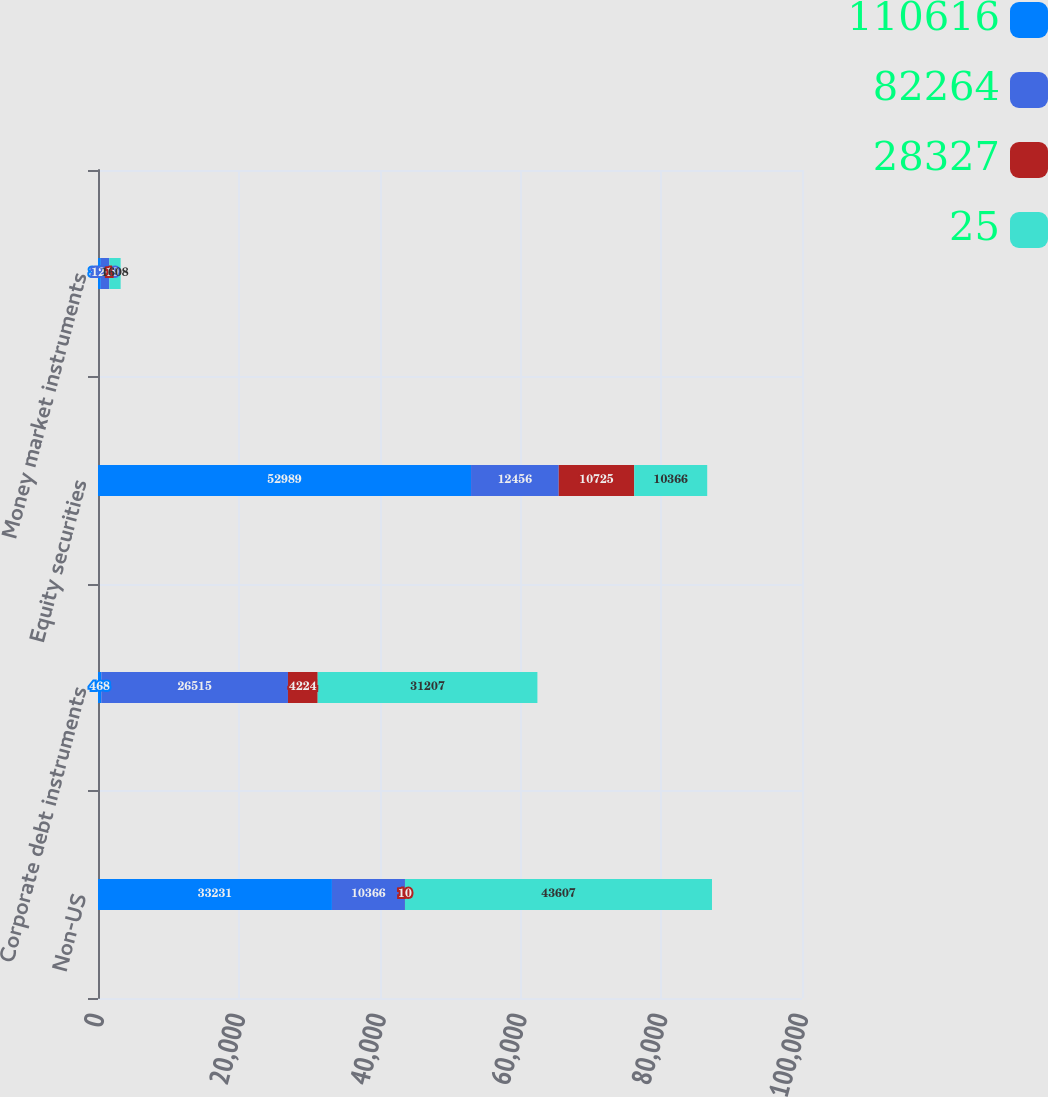<chart> <loc_0><loc_0><loc_500><loc_500><stacked_bar_chart><ecel><fcel>Non-US<fcel>Corporate debt instruments<fcel>Equity securities<fcel>Money market instruments<nl><fcel>110616<fcel>33231<fcel>468<fcel>52989<fcel>398<nl><fcel>82264<fcel>10366<fcel>26515<fcel>12456<fcel>1209<nl><fcel>28327<fcel>10<fcel>4224<fcel>10725<fcel>1<nl><fcel>25<fcel>43607<fcel>31207<fcel>10366<fcel>1608<nl></chart> 